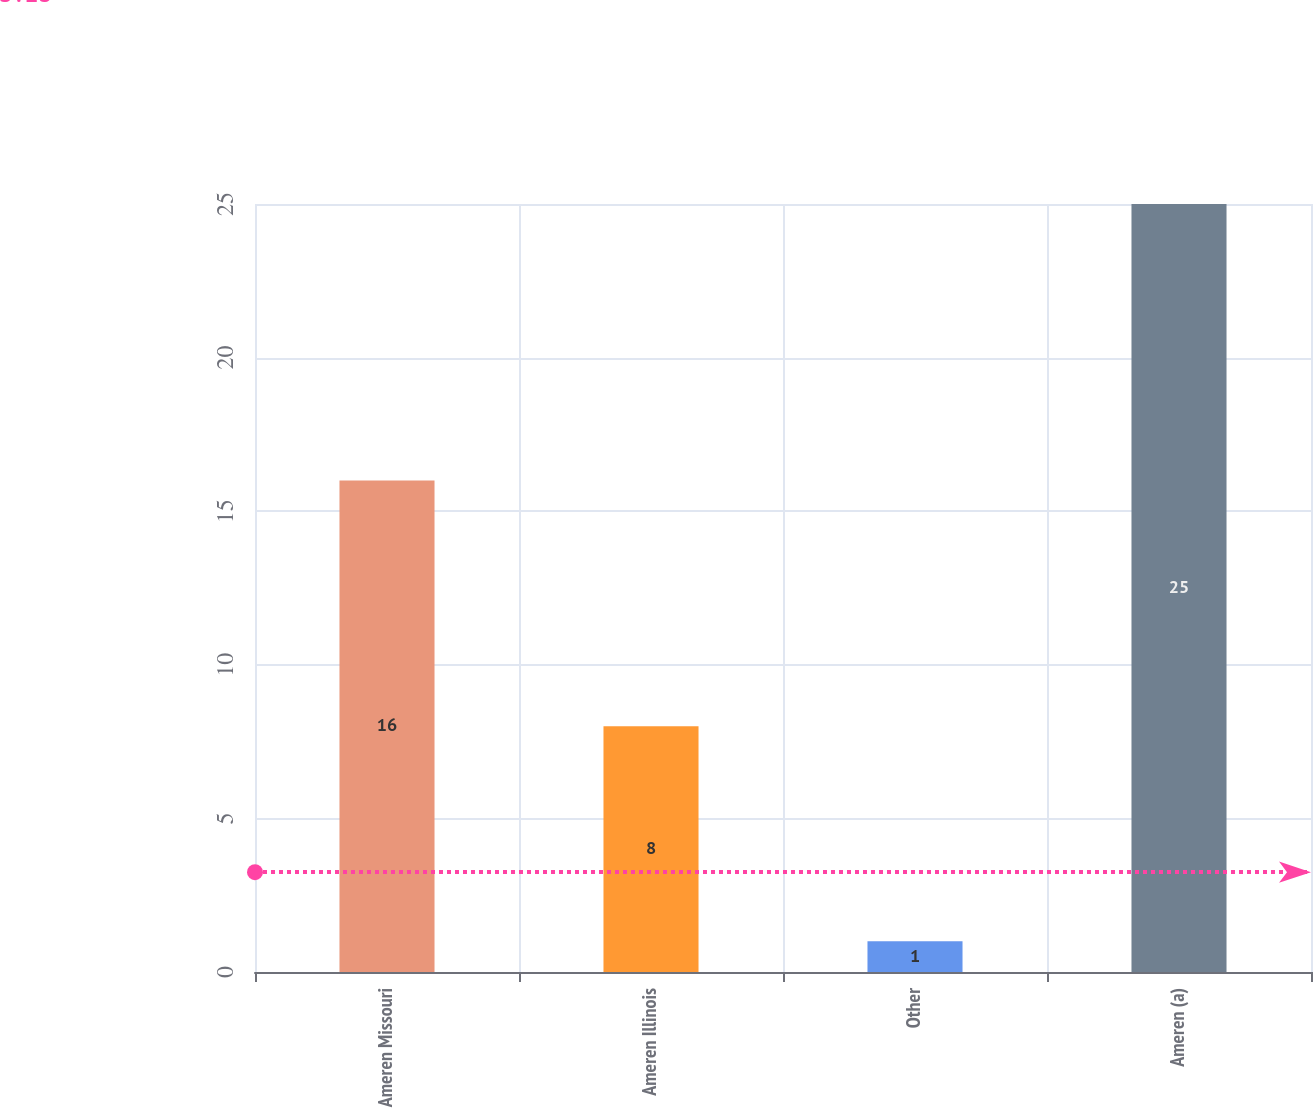Convert chart. <chart><loc_0><loc_0><loc_500><loc_500><bar_chart><fcel>Ameren Missouri<fcel>Ameren Illinois<fcel>Other<fcel>Ameren (a)<nl><fcel>16<fcel>8<fcel>1<fcel>25<nl></chart> 